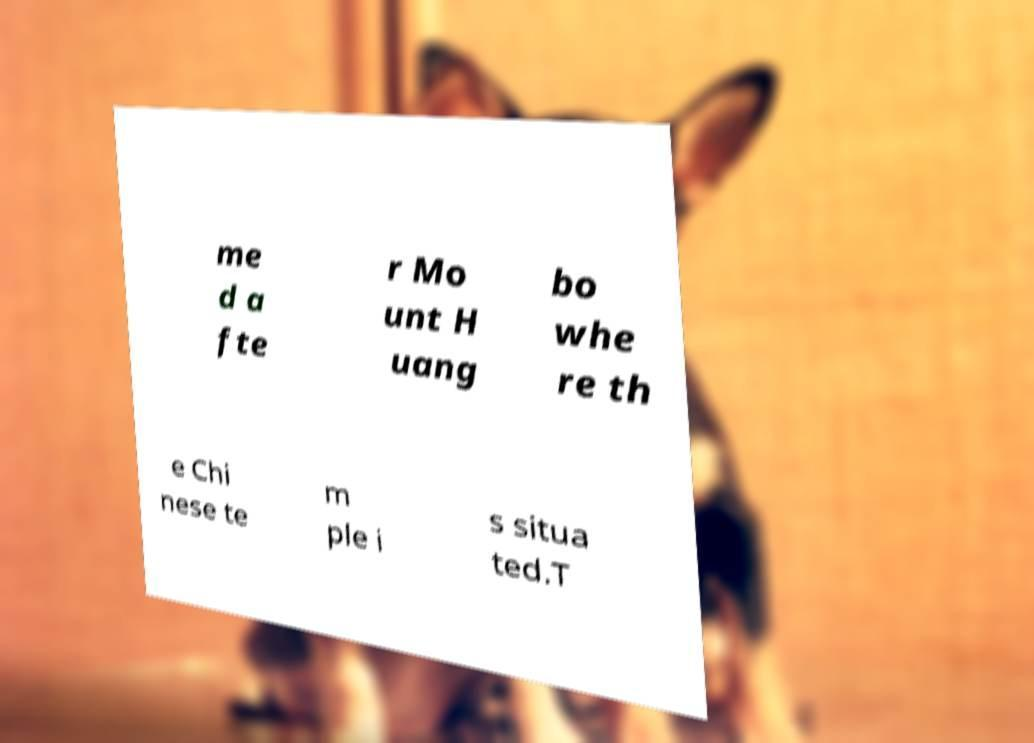There's text embedded in this image that I need extracted. Can you transcribe it verbatim? me d a fte r Mo unt H uang bo whe re th e Chi nese te m ple i s situa ted.T 